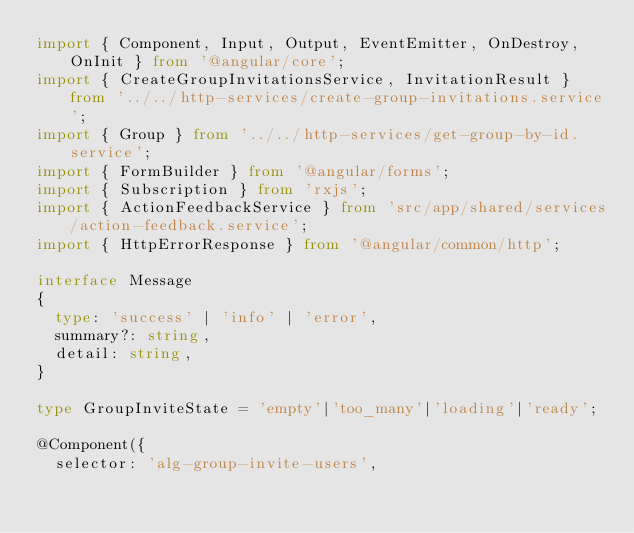<code> <loc_0><loc_0><loc_500><loc_500><_TypeScript_>import { Component, Input, Output, EventEmitter, OnDestroy, OnInit } from '@angular/core';
import { CreateGroupInvitationsService, InvitationResult } from '../../http-services/create-group-invitations.service';
import { Group } from '../../http-services/get-group-by-id.service';
import { FormBuilder } from '@angular/forms';
import { Subscription } from 'rxjs';
import { ActionFeedbackService } from 'src/app/shared/services/action-feedback.service';
import { HttpErrorResponse } from '@angular/common/http';

interface Message
{
  type: 'success' | 'info' | 'error',
  summary?: string,
  detail: string,
}

type GroupInviteState = 'empty'|'too_many'|'loading'|'ready';

@Component({
  selector: 'alg-group-invite-users',</code> 